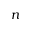<formula> <loc_0><loc_0><loc_500><loc_500>n</formula> 